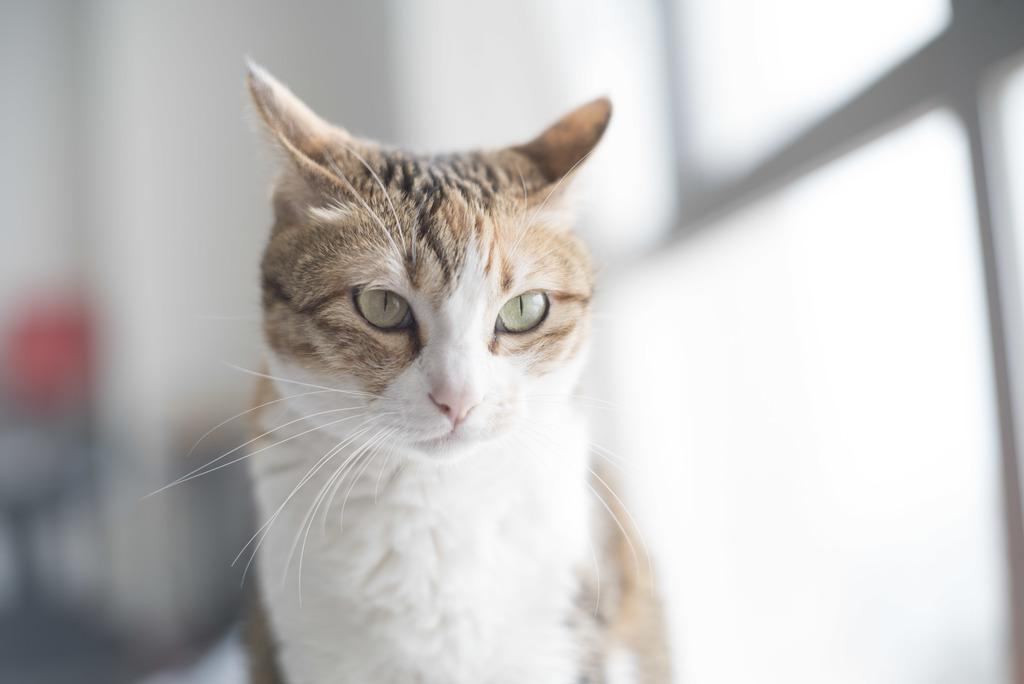What type of animal is in the picture? There is a cat in the picture. Can you describe the background of the picture? The background of the picture is blurry. What grade is the cat in the picture? The cat is not a student, so it is not in a grade. 